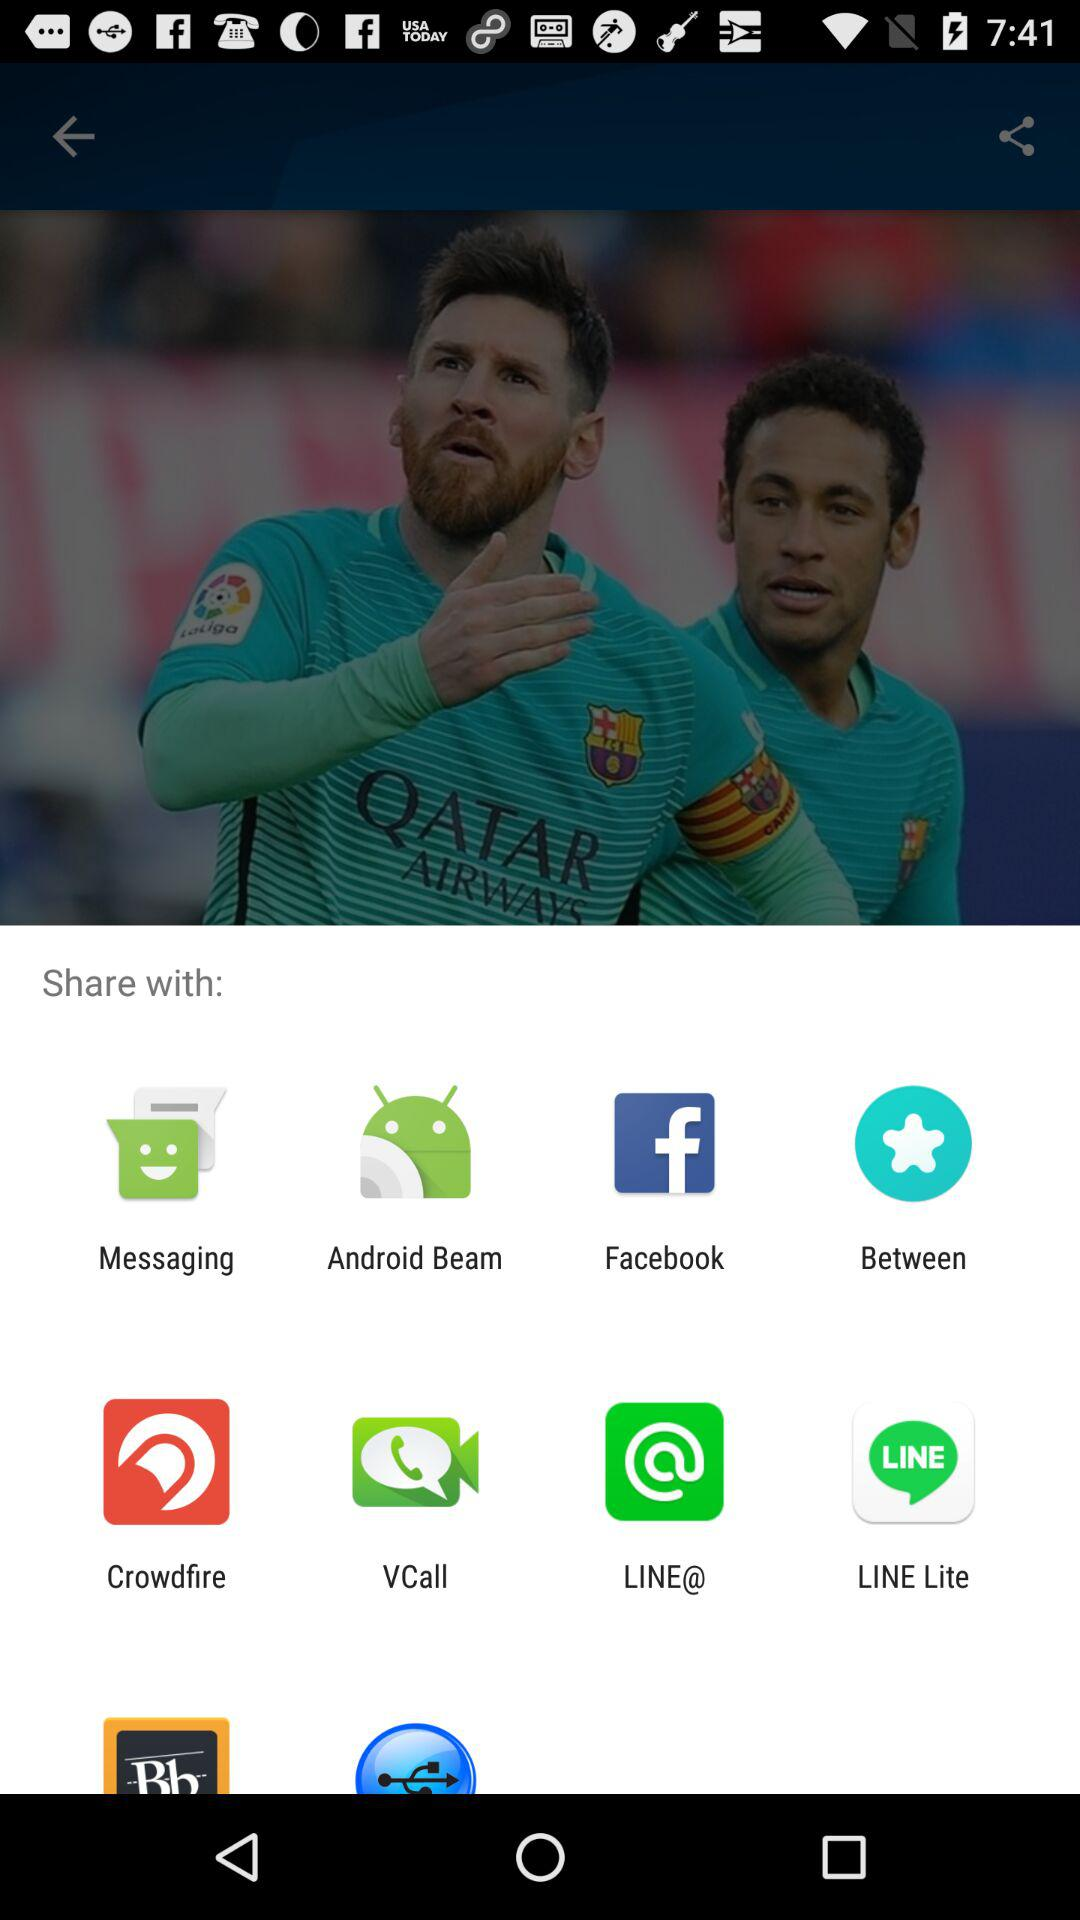What application can I use to share? The applications you can use to share are "Messaging", "Android Beam", "Facebook", "Between", "Crowdfire", "VCall", "LINE@" and "LINE Lite". 